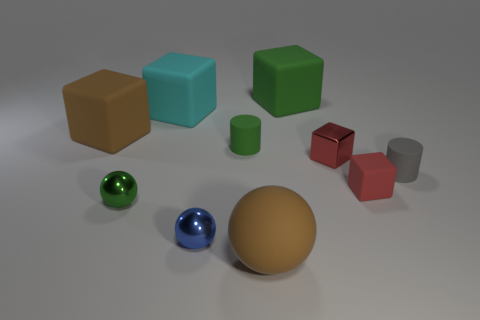Is the tiny shiny cube the same color as the large sphere?
Offer a very short reply. No. Is the shape of the large thing that is in front of the red matte object the same as  the large cyan thing?
Your answer should be very brief. No. How many big rubber things are both in front of the tiny green shiny thing and behind the tiny red shiny block?
Make the answer very short. 0. What is the small green cylinder made of?
Your response must be concise. Rubber. Is there any other thing that has the same color as the rubber sphere?
Your response must be concise. Yes. Does the green ball have the same material as the cyan block?
Offer a terse response. No. How many brown matte objects are in front of the green ball left of the green matte object in front of the brown block?
Keep it short and to the point. 1. How many tiny yellow things are there?
Offer a very short reply. 0. Is the number of brown matte objects that are on the right side of the tiny metal cube less than the number of metallic things that are to the right of the green cylinder?
Keep it short and to the point. Yes. Are there fewer big cyan things that are behind the cyan cube than red shiny cylinders?
Your response must be concise. No. 